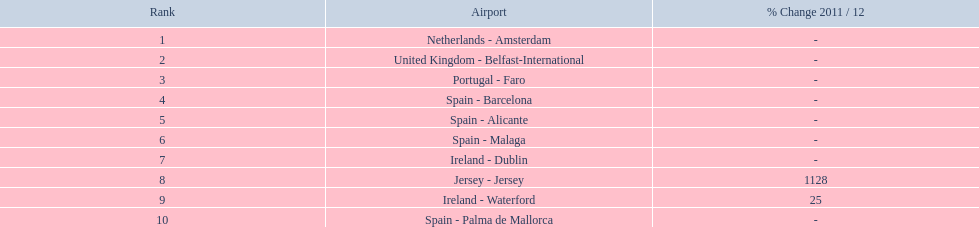What is the best rank? 1. What is the airport? Netherlands - Amsterdam. 